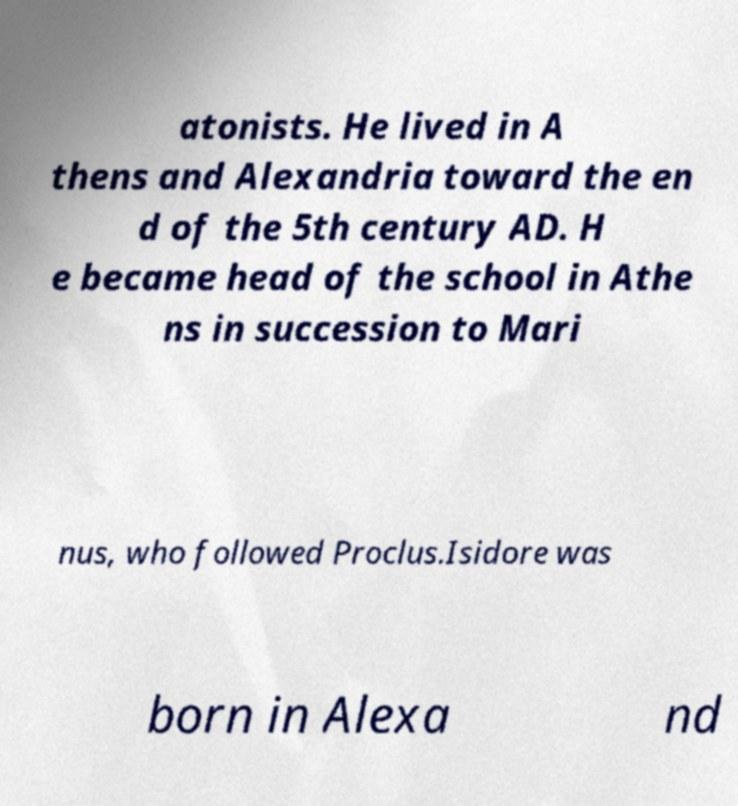For documentation purposes, I need the text within this image transcribed. Could you provide that? atonists. He lived in A thens and Alexandria toward the en d of the 5th century AD. H e became head of the school in Athe ns in succession to Mari nus, who followed Proclus.Isidore was born in Alexa nd 